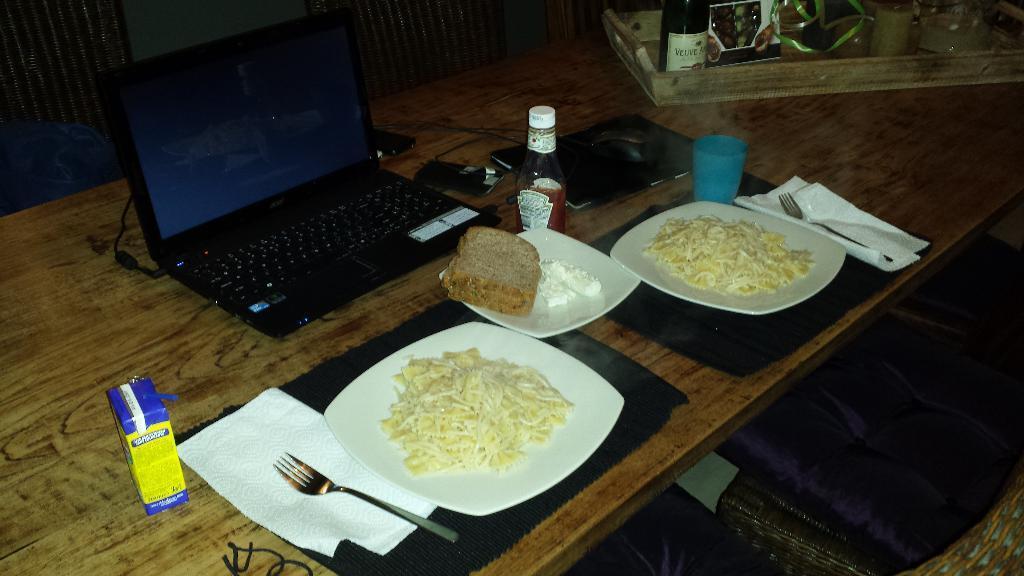How would you summarize this image in a sentence or two? In this picture there is box, tissue, fork, noodles , brown bread in plate. There is a cup and a bottle. There is a laptop, phone and few items in a tray. 